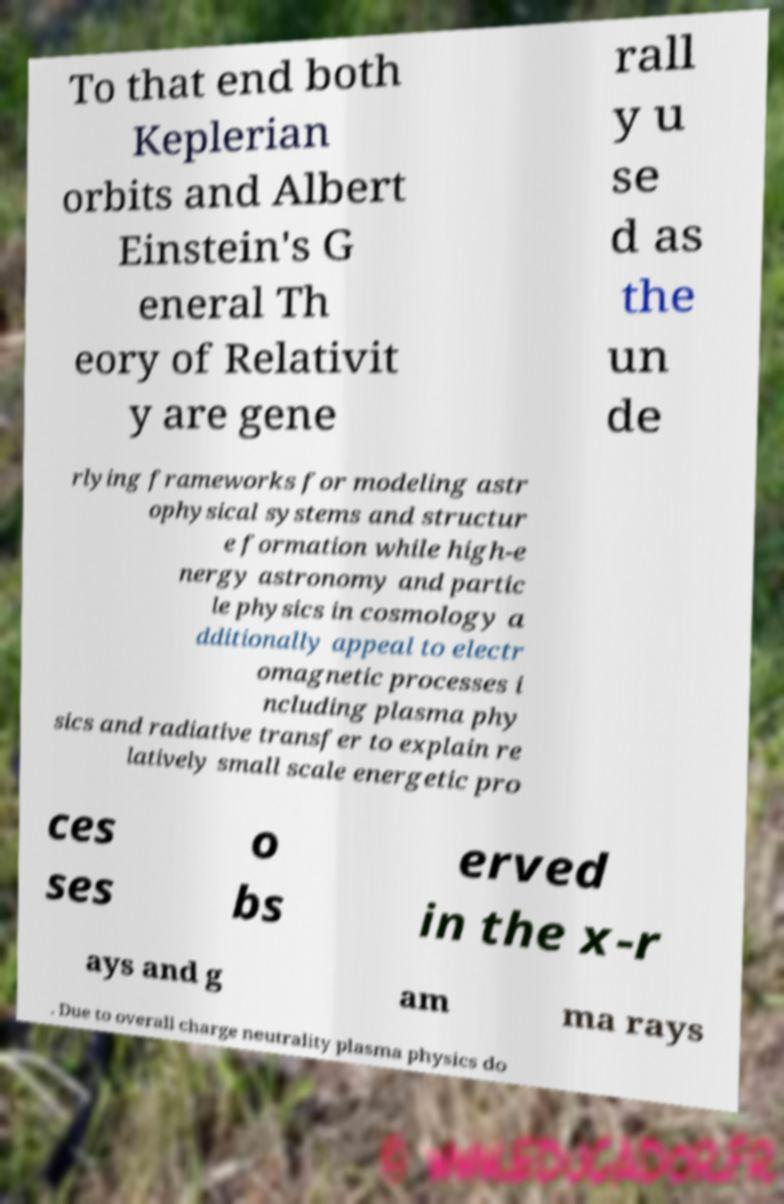Could you assist in decoding the text presented in this image and type it out clearly? To that end both Keplerian orbits and Albert Einstein's G eneral Th eory of Relativit y are gene rall y u se d as the un de rlying frameworks for modeling astr ophysical systems and structur e formation while high-e nergy astronomy and partic le physics in cosmology a dditionally appeal to electr omagnetic processes i ncluding plasma phy sics and radiative transfer to explain re latively small scale energetic pro ces ses o bs erved in the x-r ays and g am ma rays . Due to overall charge neutrality plasma physics do 